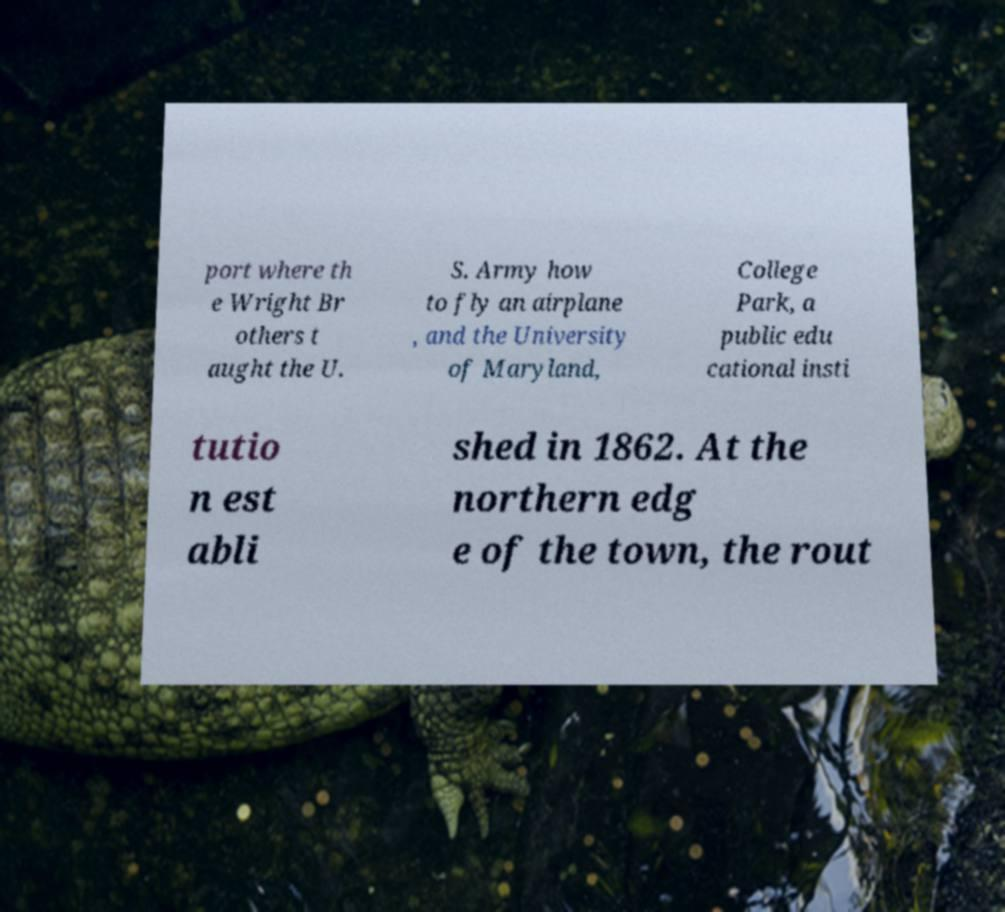Please identify and transcribe the text found in this image. port where th e Wright Br others t aught the U. S. Army how to fly an airplane , and the University of Maryland, College Park, a public edu cational insti tutio n est abli shed in 1862. At the northern edg e of the town, the rout 